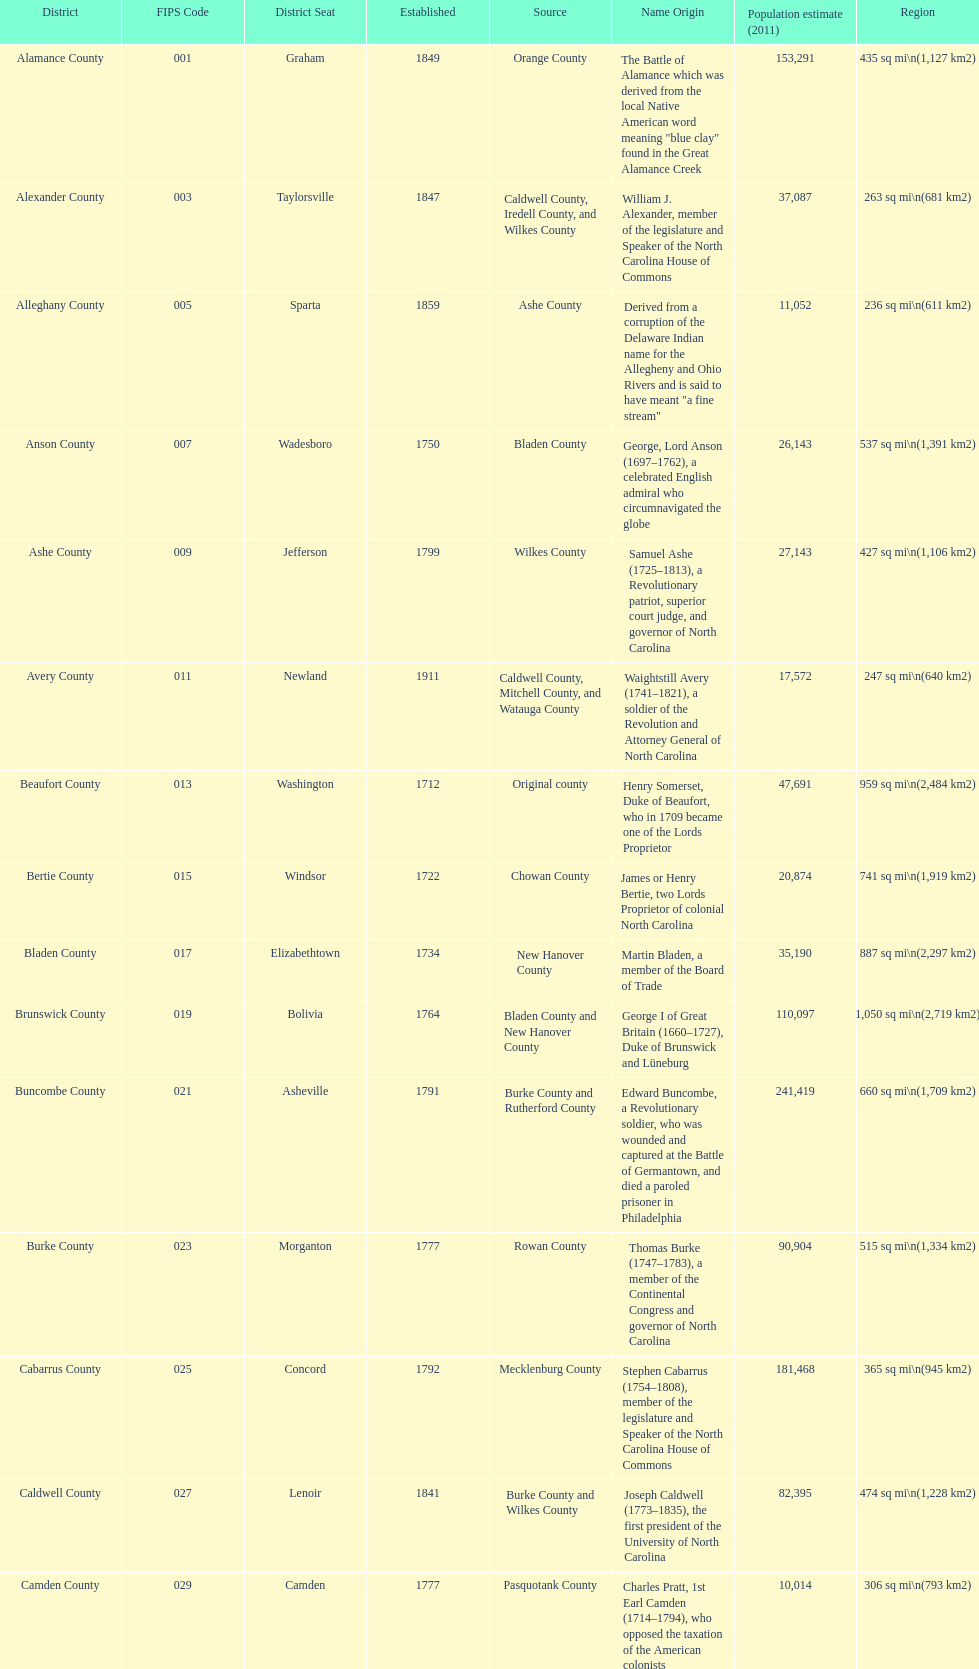What number of counties are named for us presidents? 3. 